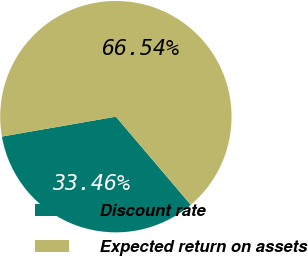Convert chart to OTSL. <chart><loc_0><loc_0><loc_500><loc_500><pie_chart><fcel>Discount rate<fcel>Expected return on assets<nl><fcel>33.46%<fcel>66.54%<nl></chart> 